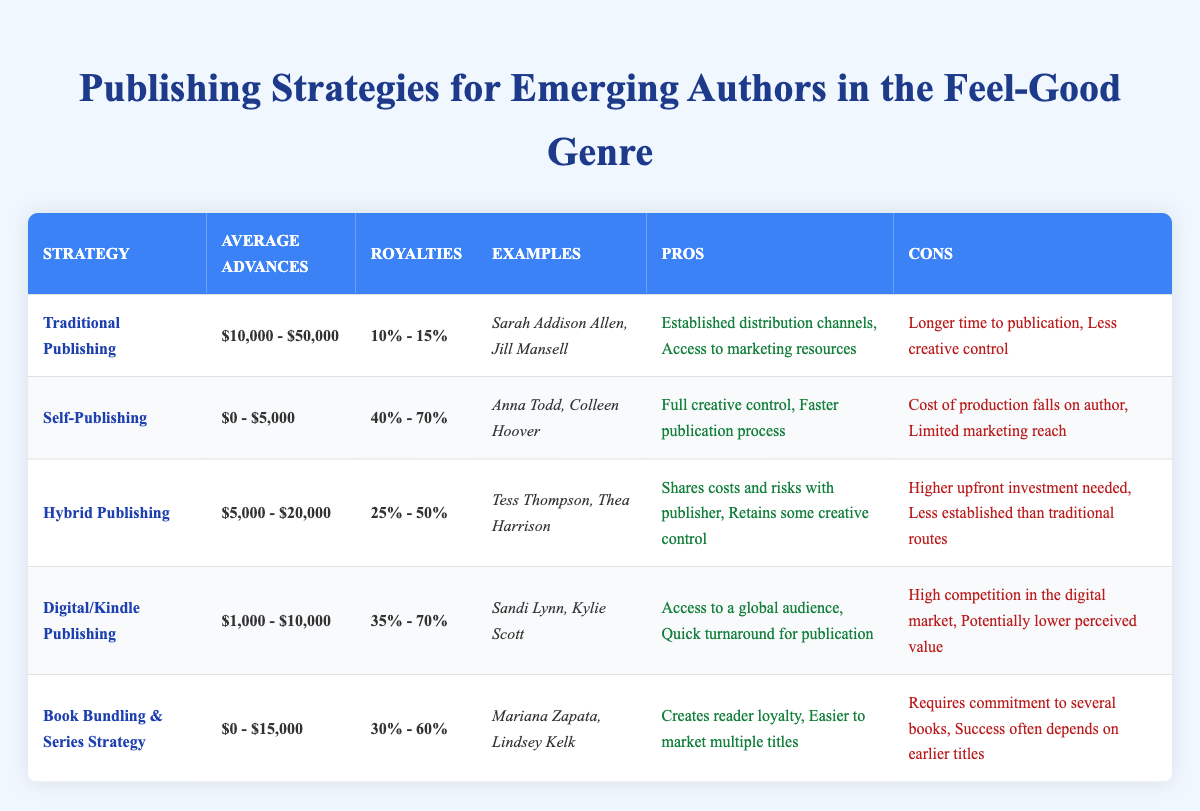What is the average advance for self-publishing? The table lists the average advancements for self-publishing as **$0 - $5,000**. This value represents the typical range for this publishing strategy.
Answer: $0 - $5,000 Which publishing strategy offers the highest royalty percentage? The royalty percentage for self-publishing is listed as **40% - 70%**, which is the highest among all strategies in the table.
Answer: Self-publishing Name one example of an author who has used traditional publishing. The authors listed under traditional publishing in the table include **Sarah Addison Allen** and **Jill Mansell**. Therefore, either of them could be a valid example.
Answer: Sarah Addison Allen How much do authors earn on average with hybrid publishing? The average advances for hybrid publishing are shown as **$5,000 - $20,000**. This range represents the expected earnings from this publishing option.
Answer: $5,000 - $20,000 Does digital publishing have a potential drawback? The table states that a con of digital publishing is **High competition in the digital market**, indicating that this is indeed a potential drawback of this strategy.
Answer: Yes What is the typical royalty range for book bundling and series strategy? The table indicates that the royalty percentage for book bundling and series strategy is **30% - 60%**. This presents the typical earnings for authors using this approach.
Answer: 30% - 60% Which two publishing strategies provide the quickest turnaround for publication? The table highlights that self-publishing and digital publishing both emphasize quicker publication processes, as noted in their pros.
Answer: Self-publishing and digital publishing If an author chooses traditional publishing, what is one significant downside? One con of traditional publishing listed in the table is **Longer time to publication**, which highlights a significant downside of choosing this strategy.
Answer: Longer time to publication How does the average advance for digital publishing compare to that of traditional publishing? The average advances for digital publishing are **$1,000 - $10,000**, while traditional publishing ranges from **$10,000 - $50,000**. Comparing the two shows that traditional publishing generally offers higher average advances.
Answer: Traditional publishing has higher average advances What is the average royalty difference when comparing self-publishing to hybrid publishing? The average royalty for self-publishing is **40% - 70%**, while hybrid publishing is **25% - 50%**. The difference represents a lower royalty range in hybrid compared to self-publishing, indicating that hybrid publishing offers about **15% fewer** at the average ranges.
Answer: 15% fewer at average ranges 